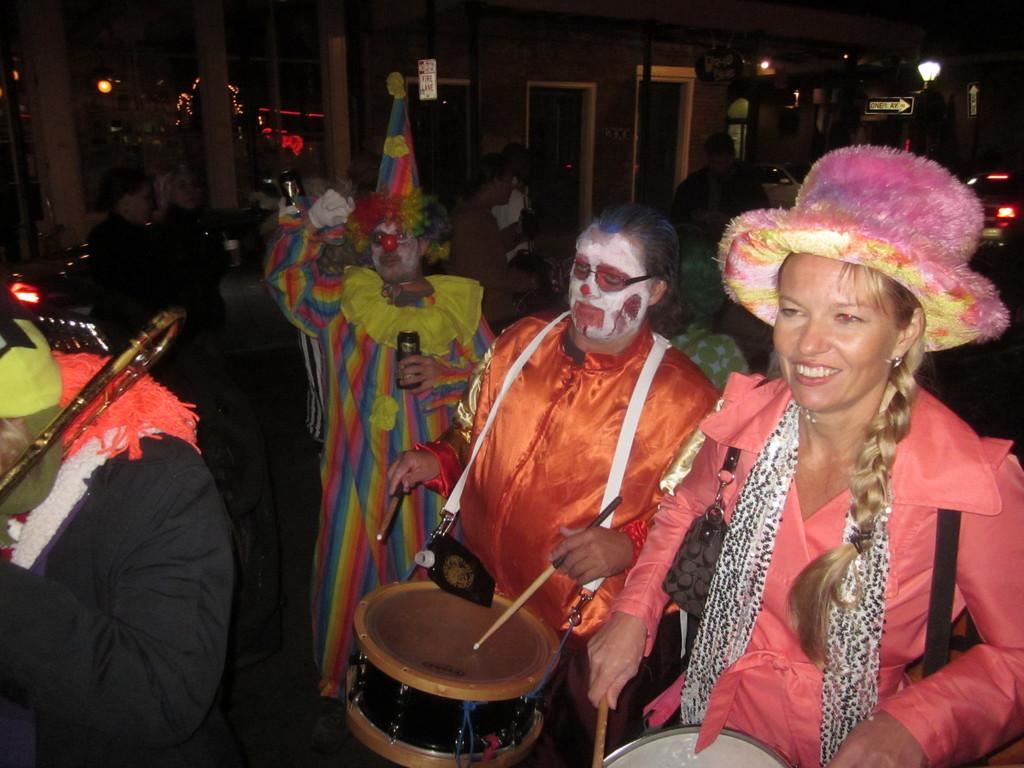What are the two persons in the image doing? The two persons in the image are playing drums. What other musical instrument can be seen in the image? There is a person playing a trumpet in the image. What can be seen in the background of the image? Many people and a building are visible in the background of the image. What type of business is being conducted through the window in the image? There is no window present in the image, and therefore no business can be conducted through it. 